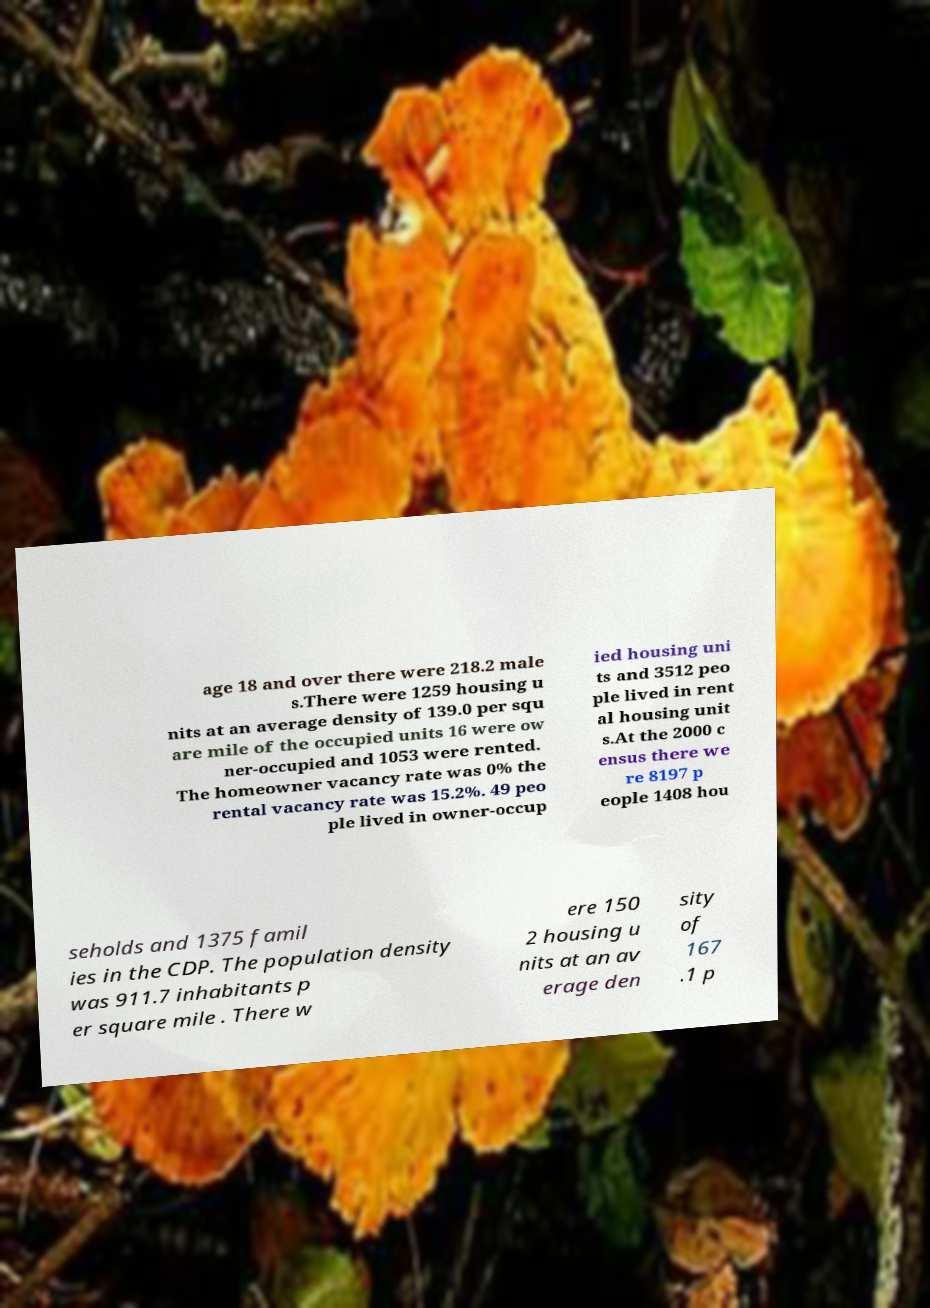I need the written content from this picture converted into text. Can you do that? age 18 and over there were 218.2 male s.There were 1259 housing u nits at an average density of 139.0 per squ are mile of the occupied units 16 were ow ner-occupied and 1053 were rented. The homeowner vacancy rate was 0% the rental vacancy rate was 15.2%. 49 peo ple lived in owner-occup ied housing uni ts and 3512 peo ple lived in rent al housing unit s.At the 2000 c ensus there we re 8197 p eople 1408 hou seholds and 1375 famil ies in the CDP. The population density was 911.7 inhabitants p er square mile . There w ere 150 2 housing u nits at an av erage den sity of 167 .1 p 